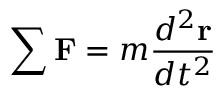Convert formula to latex. <formula><loc_0><loc_0><loc_500><loc_500>\sum F = m { \frac { d ^ { 2 } r } { d t ^ { 2 } } }</formula> 